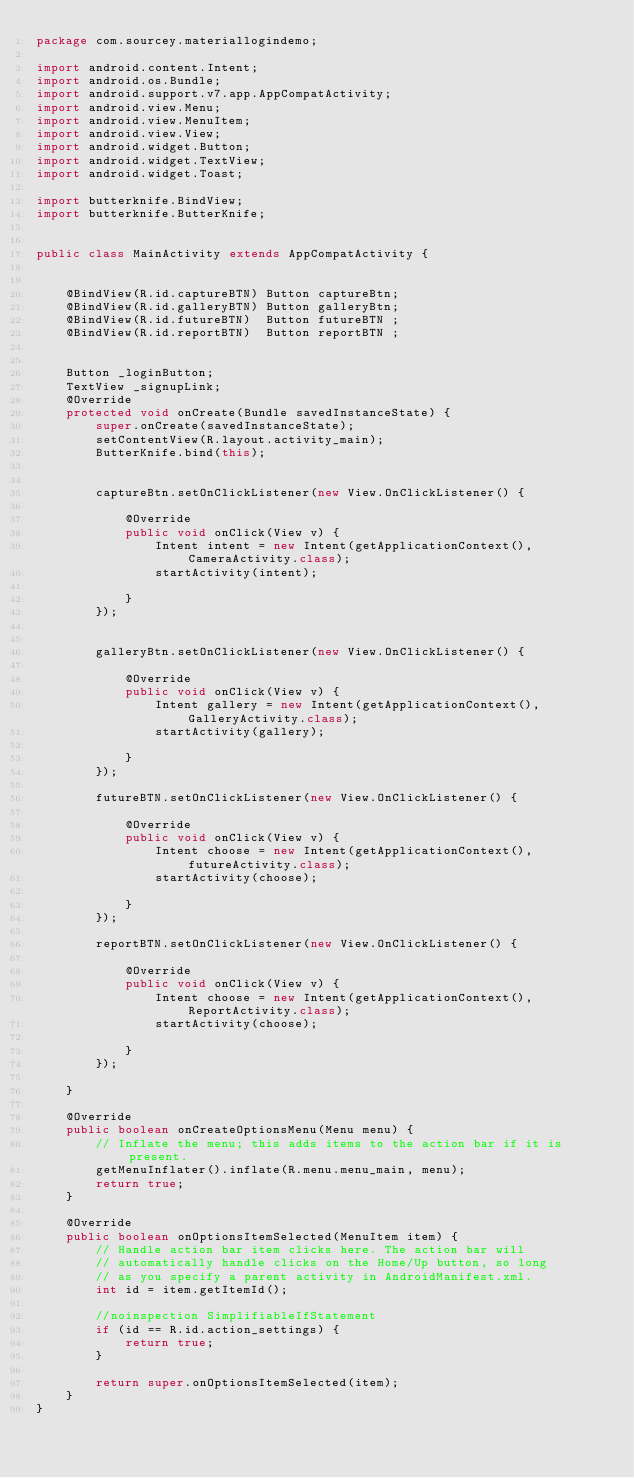Convert code to text. <code><loc_0><loc_0><loc_500><loc_500><_Java_>package com.sourcey.materiallogindemo;

import android.content.Intent;
import android.os.Bundle;
import android.support.v7.app.AppCompatActivity;
import android.view.Menu;
import android.view.MenuItem;
import android.view.View;
import android.widget.Button;
import android.widget.TextView;
import android.widget.Toast;

import butterknife.BindView;
import butterknife.ButterKnife;


public class MainActivity extends AppCompatActivity {


    @BindView(R.id.captureBTN) Button captureBtn;
    @BindView(R.id.galleryBTN) Button galleryBtn;
    @BindView(R.id.futureBTN)  Button futureBTN ;
    @BindView(R.id.reportBTN)  Button reportBTN ;


    Button _loginButton;
    TextView _signupLink;
    @Override
    protected void onCreate(Bundle savedInstanceState) {
        super.onCreate(savedInstanceState);
        setContentView(R.layout.activity_main);
        ButterKnife.bind(this);


        captureBtn.setOnClickListener(new View.OnClickListener() {

            @Override
            public void onClick(View v) {
                Intent intent = new Intent(getApplicationContext(), CameraActivity.class);
                startActivity(intent);

            }
        });


        galleryBtn.setOnClickListener(new View.OnClickListener() {

            @Override
            public void onClick(View v) {
                Intent gallery = new Intent(getApplicationContext(), GalleryActivity.class);
                startActivity(gallery);

            }
        });

        futureBTN.setOnClickListener(new View.OnClickListener() {

            @Override
            public void onClick(View v) {
                Intent choose = new Intent(getApplicationContext(),futureActivity.class);
                startActivity(choose);

            }
        });

        reportBTN.setOnClickListener(new View.OnClickListener() {

            @Override
            public void onClick(View v) {
                Intent choose = new Intent(getApplicationContext(),ReportActivity.class);
                startActivity(choose);

            }
        });

    }

    @Override
    public boolean onCreateOptionsMenu(Menu menu) {
        // Inflate the menu; this adds items to the action bar if it is present.
        getMenuInflater().inflate(R.menu.menu_main, menu);
        return true;
    }

    @Override
    public boolean onOptionsItemSelected(MenuItem item) {
        // Handle action bar item clicks here. The action bar will
        // automatically handle clicks on the Home/Up button, so long
        // as you specify a parent activity in AndroidManifest.xml.
        int id = item.getItemId();

        //noinspection SimplifiableIfStatement
        if (id == R.id.action_settings) {
            return true;
        }

        return super.onOptionsItemSelected(item);
    }
}
</code> 